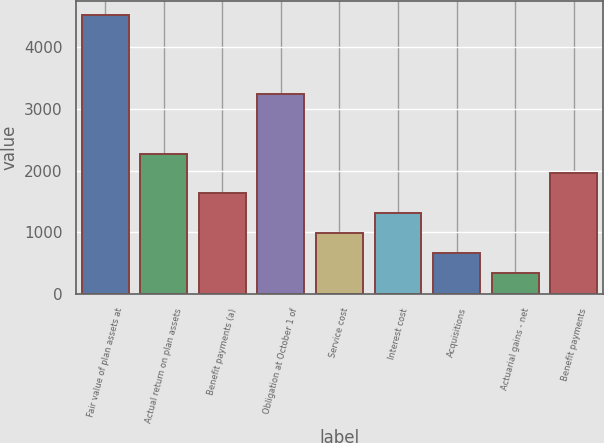Convert chart to OTSL. <chart><loc_0><loc_0><loc_500><loc_500><bar_chart><fcel>Fair value of plan assets at<fcel>Actual return on plan assets<fcel>Benefit payments (a)<fcel>Obligation at October 1 of<fcel>Service cost<fcel>Interest cost<fcel>Acquisitions<fcel>Actuarial gains - net<fcel>Benefit payments<nl><fcel>4529.8<fcel>2277.9<fcel>1634.5<fcel>3243<fcel>991.1<fcel>1312.8<fcel>669.4<fcel>347.7<fcel>1956.2<nl></chart> 